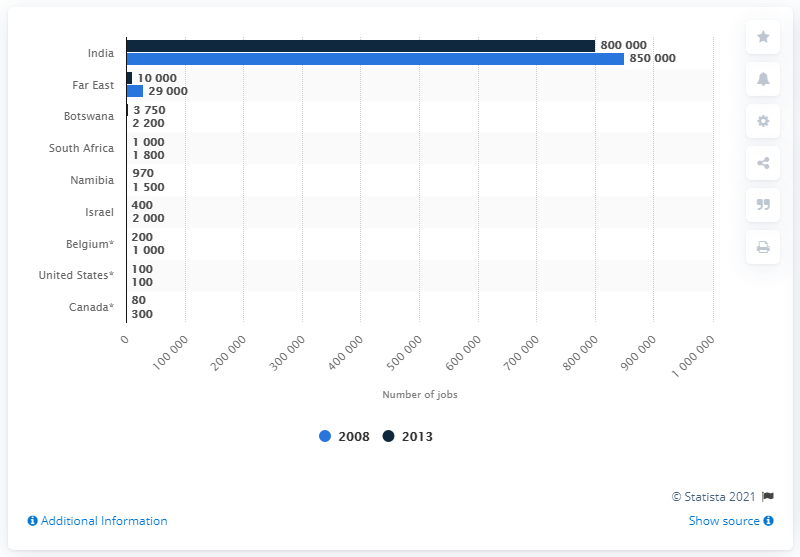Point out several critical features in this image. There were approximately 10,000 diamond cutting and polishing jobs in the Far East in 2013. 